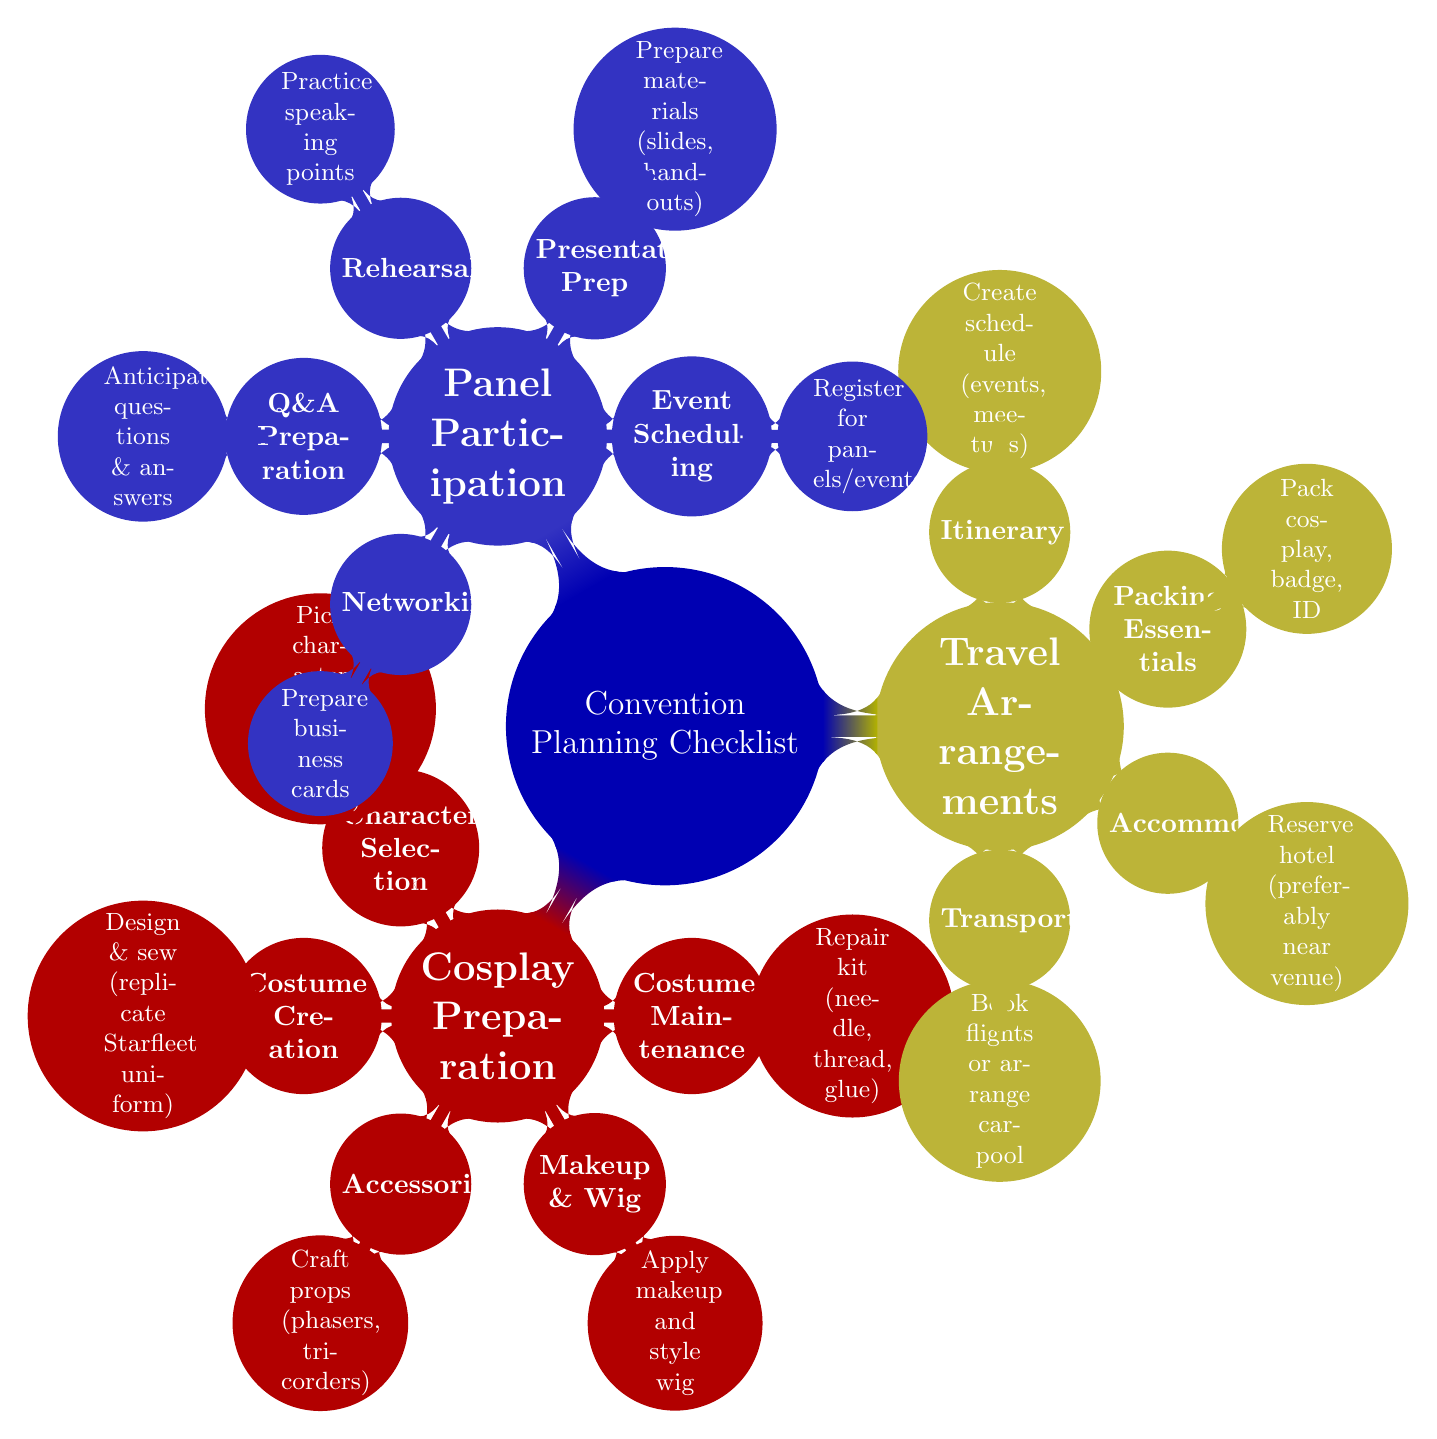What's the main topic of the diagram? The diagram centers around convention planning, specifically a checklist for key preparations regarding cosplay, travel, and panel participation.
Answer: Convention Planning Checklist How many main child categories does the diagram contain? The diagram contains three main child categories stemming from the central topic: Cosplay Preparation, Travel Arrangements, and Panel Participation.
Answer: 3 What color represents Travel Arrangements in the diagram? Travel Arrangements is represented in yellow, specifically the color designated as trekyellow in the diagram.
Answer: Yellow Which subcategory under Panel Participation focuses on audience interaction? The subcategory that focuses on audience interaction is Q&A Preparation, which advises on anticipating questions and answers.
Answer: Q&A Preparation What is the primary task associated with Costume Maintenance? The primary task associated with Costume Maintenance is having a repair kit that includes items like needle, thread, and glue for emergency fixes.
Answer: Repair kit How is the relationship between Costume Creation and Character Selection described in the diagram? Costume Creation and Character Selection are both subcategories under the main category of Cosplay Preparation, indicating they are part of the same preparation process for a convention.
Answer: They are both subcategories of Cosplay Preparation What specific action is suggested under Packing Essentials? Packing Essentials includes the action of packing cosplay items, badge, and ID, which are crucial for convention participation.
Answer: Pack cosplay, badge, ID How many elements are listed under the category of Presentation Prep? There is one key element listed under Presentation Prep, which is to prepare materials such as slides and handouts for the presentation.
Answer: 1 Which child node includes the component of schedule creation? The component of schedule creation is included under the Itinerary child node, which is a part of the Travel Arrangements category.
Answer: Itinerary 